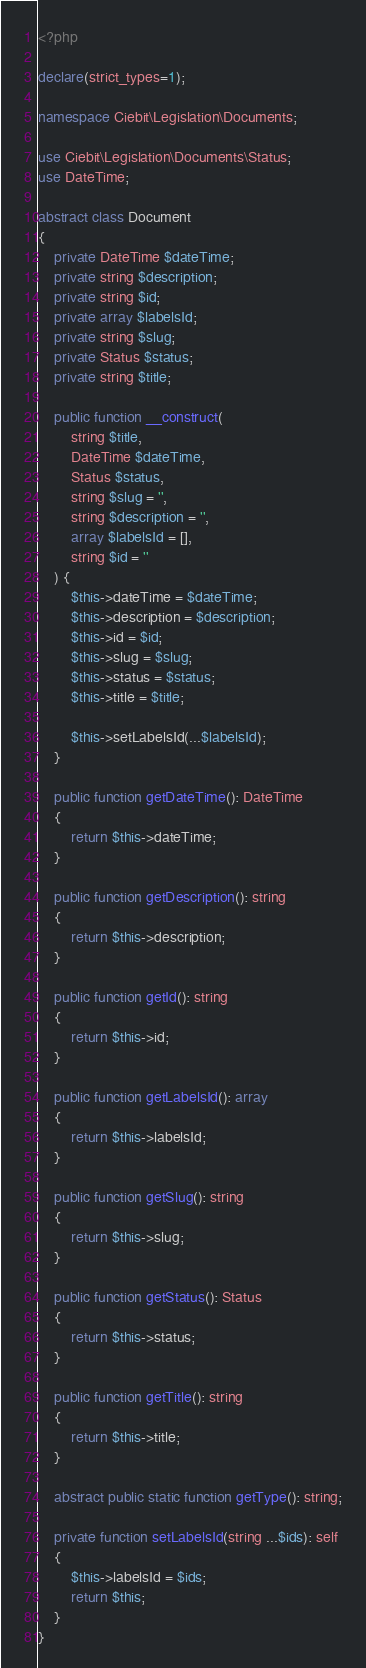<code> <loc_0><loc_0><loc_500><loc_500><_PHP_><?php

declare(strict_types=1);

namespace Ciebit\Legislation\Documents;

use Ciebit\Legislation\Documents\Status;
use DateTime;

abstract class Document
{
    private DateTime $dateTime;
    private string $description;
    private string $id;
    private array $labelsId;
    private string $slug;
    private Status $status;
    private string $title;

    public function __construct(
        string $title,
        DateTime $dateTime,
        Status $status,
        string $slug = '',
        string $description = '',
        array $labelsId = [],
        string $id = ''
    ) {
        $this->dateTime = $dateTime;
        $this->description = $description;
        $this->id = $id;
        $this->slug = $slug;
        $this->status = $status;
        $this->title = $title;

        $this->setLabelsId(...$labelsId);
    }

    public function getDateTime(): DateTime
    {
        return $this->dateTime;
    }

    public function getDescription(): string
    {
        return $this->description;
    }

    public function getId(): string
    {
        return $this->id;
    }

    public function getLabelsId(): array
    {
        return $this->labelsId;
    }

    public function getSlug(): string
    {
        return $this->slug;
    }

    public function getStatus(): Status
    {
        return $this->status;
    }

    public function getTitle(): string
    {
        return $this->title;
    }

    abstract public static function getType(): string;

    private function setLabelsId(string ...$ids): self
    {
        $this->labelsId = $ids;
        return $this;
    }
}
</code> 